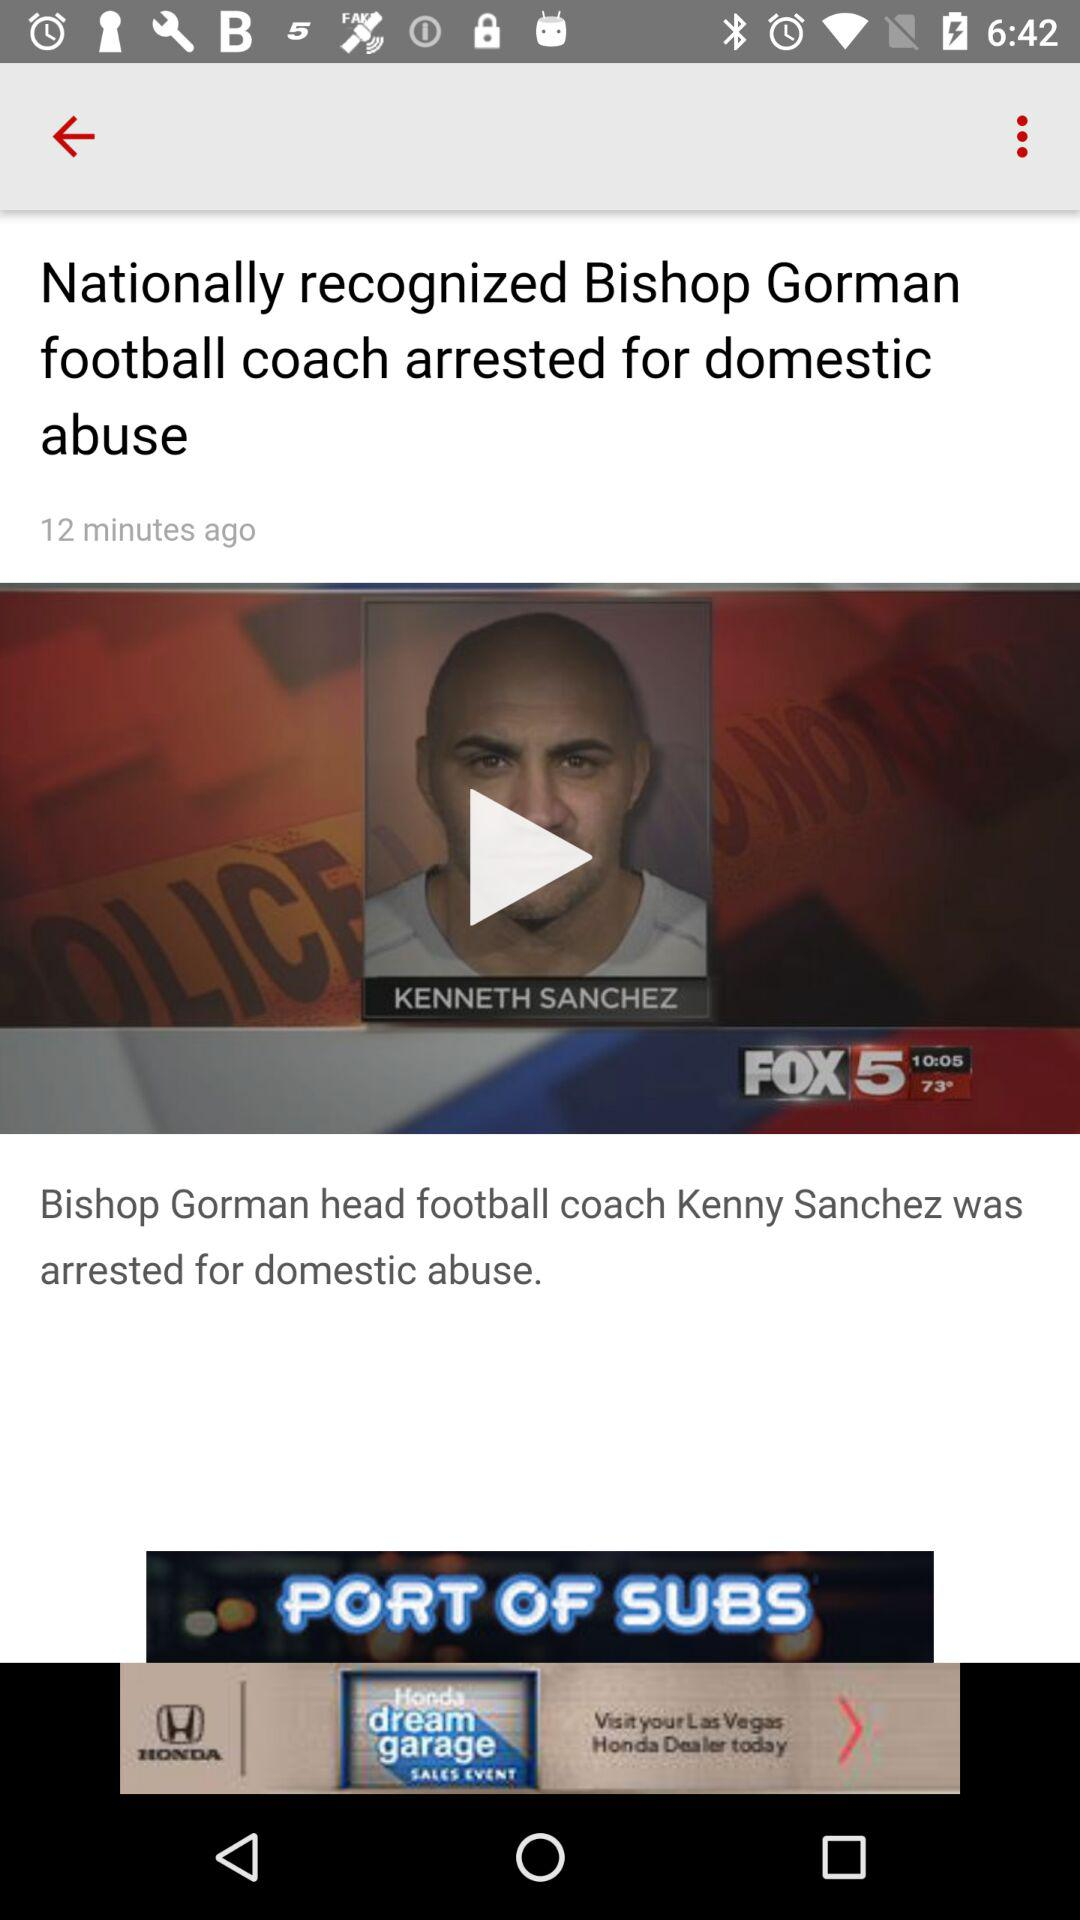When was the news posted? The news was posted 12 minutes ago. 